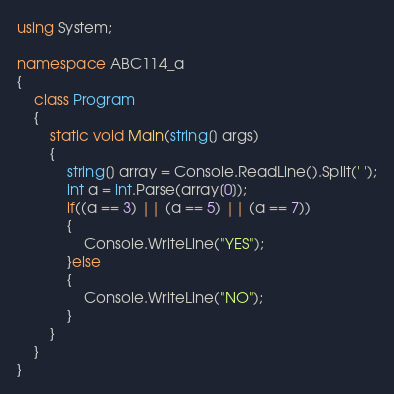Convert code to text. <code><loc_0><loc_0><loc_500><loc_500><_C#_>using System;

namespace ABC114_a
{
    class Program
    {
        static void Main(string[] args)
        {
            string[] array = Console.ReadLine().Split(' ');
            int a = int.Parse(array[0]);
            if((a == 3) || (a == 5) || (a == 7))
            {
                Console.WriteLine("YES");
            }else
            {
                Console.WriteLine("NO");
            }
        }
    }
}
</code> 